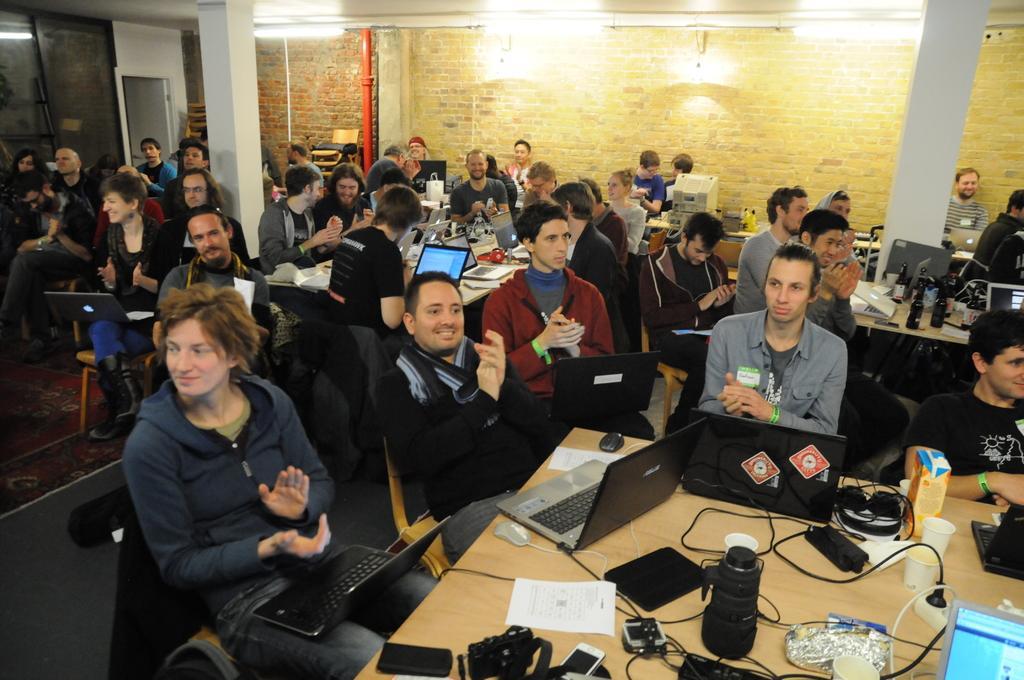Please provide a concise description of this image. In this picture we can see a few laptops, cups, box, bottles, aluminium foil, phones, camera, headsets, computer and other objects are visible on the tables. We can see a few people sitting on the chair. There is a glass, some lights on a top and a brick wall is visible in the background. 